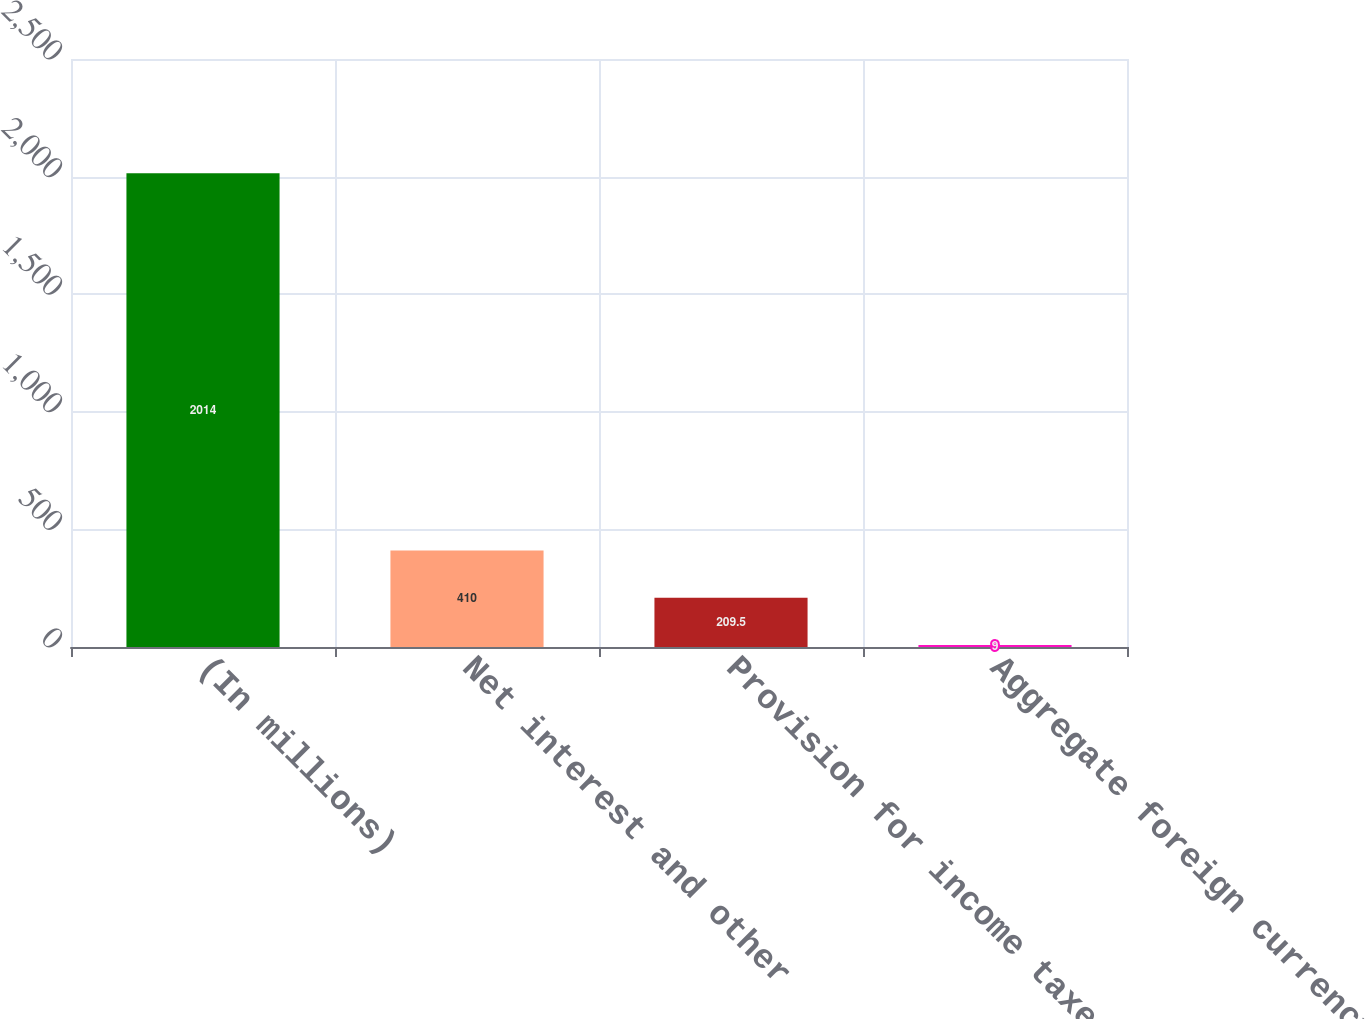Convert chart. <chart><loc_0><loc_0><loc_500><loc_500><bar_chart><fcel>(In millions)<fcel>Net interest and other<fcel>Provision for income taxes<fcel>Aggregate foreign currency<nl><fcel>2014<fcel>410<fcel>209.5<fcel>9<nl></chart> 